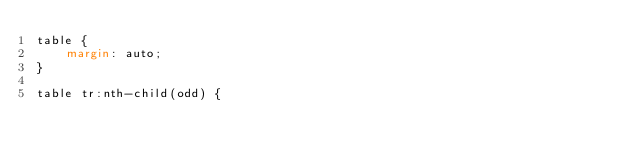Convert code to text. <code><loc_0><loc_0><loc_500><loc_500><_CSS_>table {
    margin: auto;
}

table tr:nth-child(odd) {</code> 